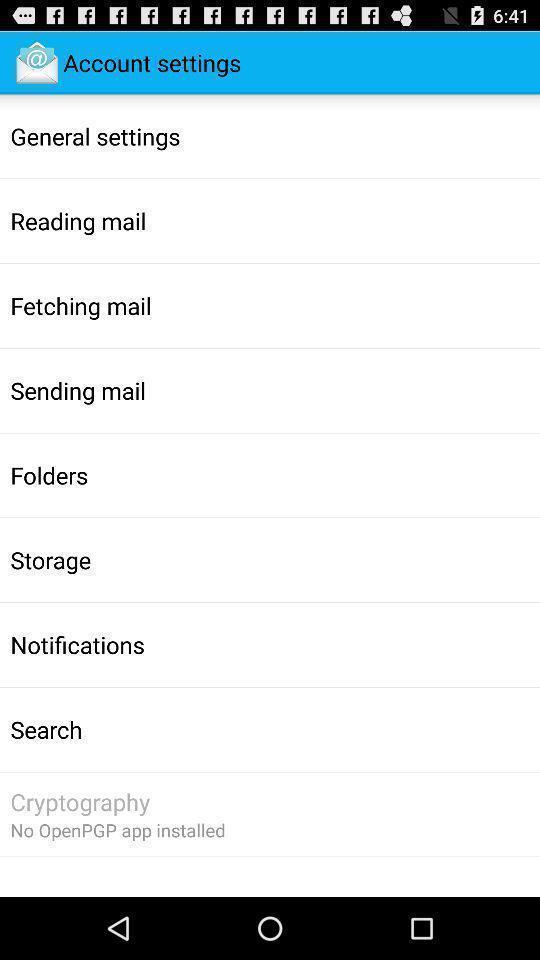Tell me what you see in this picture. Page showing the options in settings. 